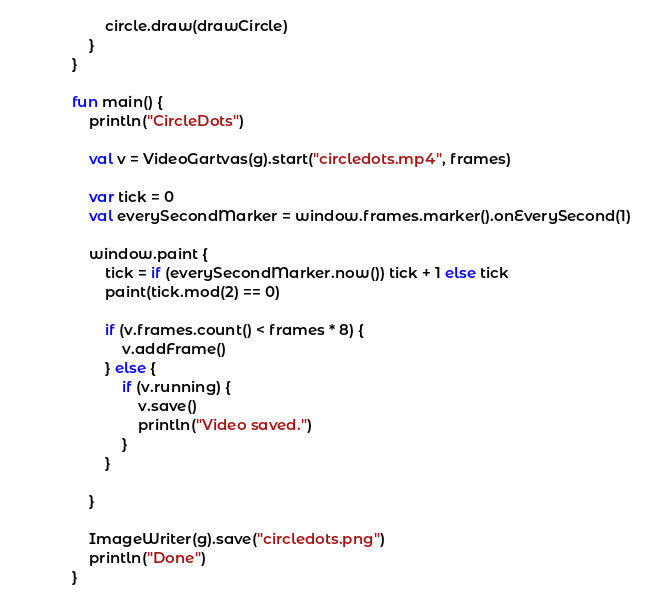Convert code to text. <code><loc_0><loc_0><loc_500><loc_500><_Kotlin_>		circle.draw(drawCircle)
	}
}

fun main() {
	println("CircleDots")

	val v = VideoGartvas(g).start("circledots.mp4", frames)

	var tick = 0
    val everySecondMarker = window.frames.marker().onEverySecond(1)

	window.paint {
		tick = if (everySecondMarker.now()) tick + 1 else tick
		paint(tick.mod(2) == 0)

		if (v.frames.count() < frames * 8) {
			v.addFrame()
		} else {
			if (v.running) {
				v.save()
				println("Video saved.")
			}
		}

	}

	ImageWriter(g).save("circledots.png")
	println("Done")
}
</code> 